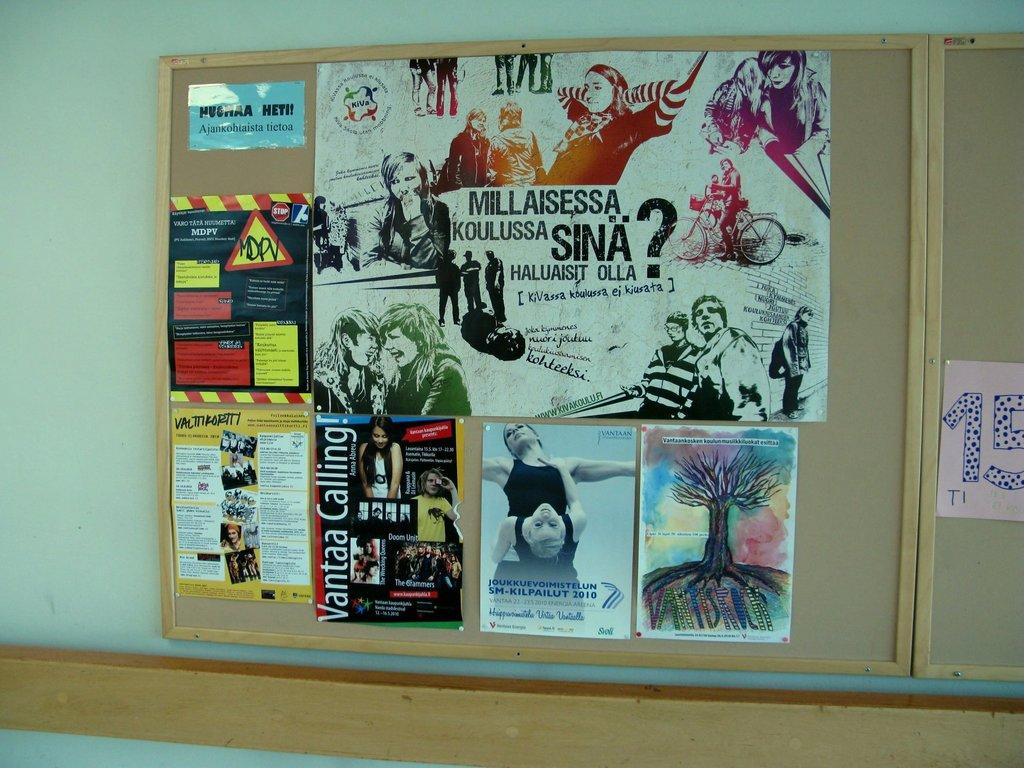What is displayed on the wooden board in the image? There are photographs and pamphlets on a wooden board in the image. Where is the wooden board located in the image? The wooden board is on a wall in the image. What type of fish can be seen swimming in the wooden board in the image? There are no fish present in the image; it features photographs and pamphlets on a wooden board. 